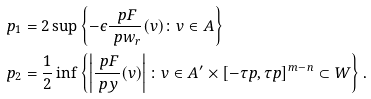Convert formula to latex. <formula><loc_0><loc_0><loc_500><loc_500>p _ { 1 } & = 2 \sup \left \{ - \epsilon \frac { \ p F } { \ p w _ { r } } ( v ) \colon v \in A \right \} \\ p _ { 2 } & = \frac { 1 } { 2 } \inf \left \{ \left | \frac { \ p F } { \ p y } ( v ) \right | \colon v \in A ^ { \prime } \times [ - \tau p , \tau p ] ^ { m - n } \subset W \right \} .</formula> 